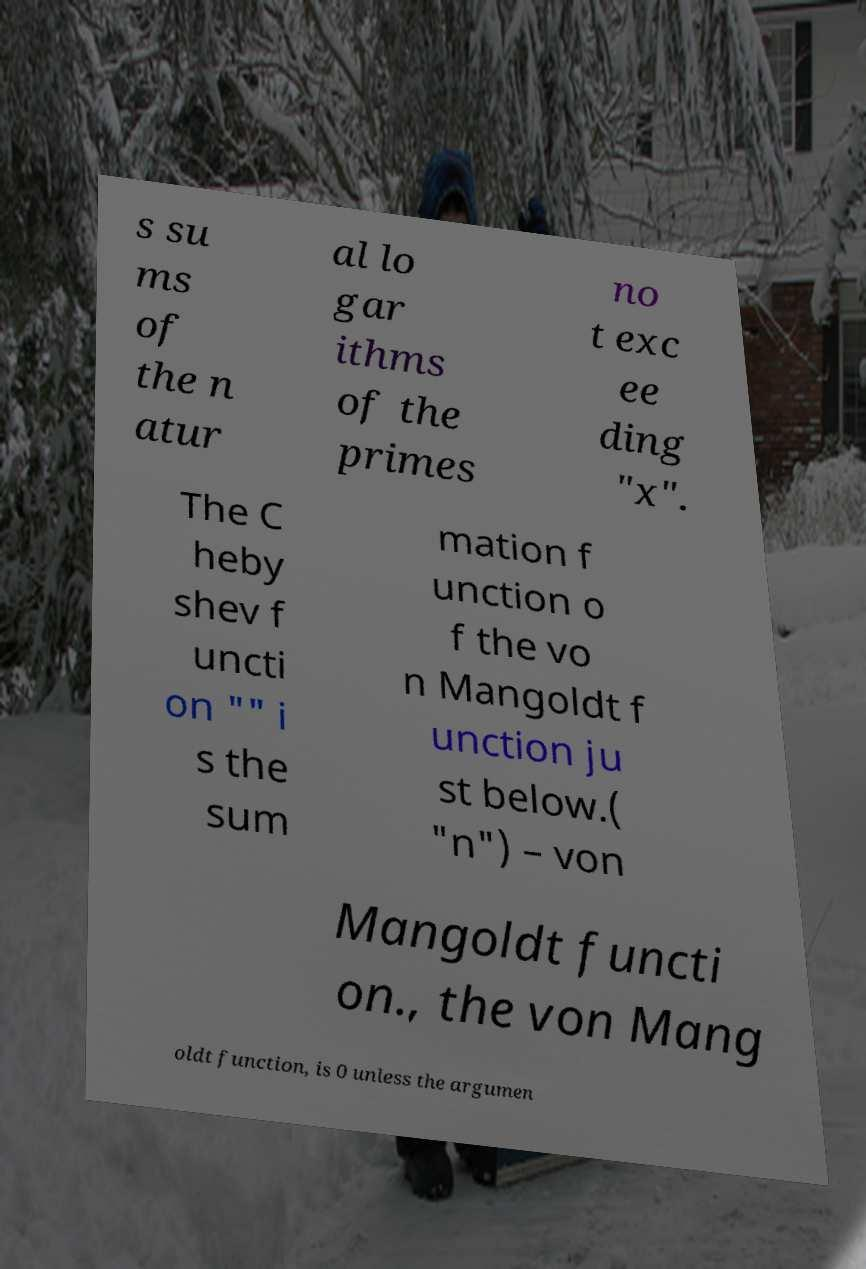Could you extract and type out the text from this image? s su ms of the n atur al lo gar ithms of the primes no t exc ee ding "x". The C heby shev f uncti on "" i s the sum mation f unction o f the vo n Mangoldt f unction ju st below.( "n") – von Mangoldt functi on., the von Mang oldt function, is 0 unless the argumen 